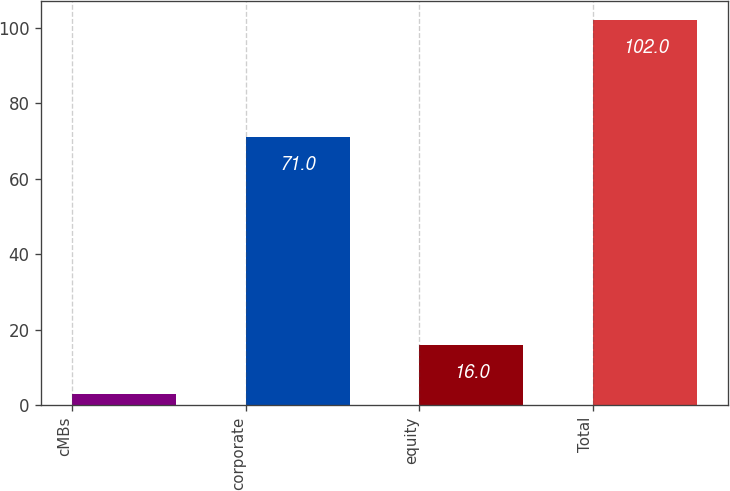<chart> <loc_0><loc_0><loc_500><loc_500><bar_chart><fcel>cMBs<fcel>corporate<fcel>equity<fcel>Total<nl><fcel>3<fcel>71<fcel>16<fcel>102<nl></chart> 